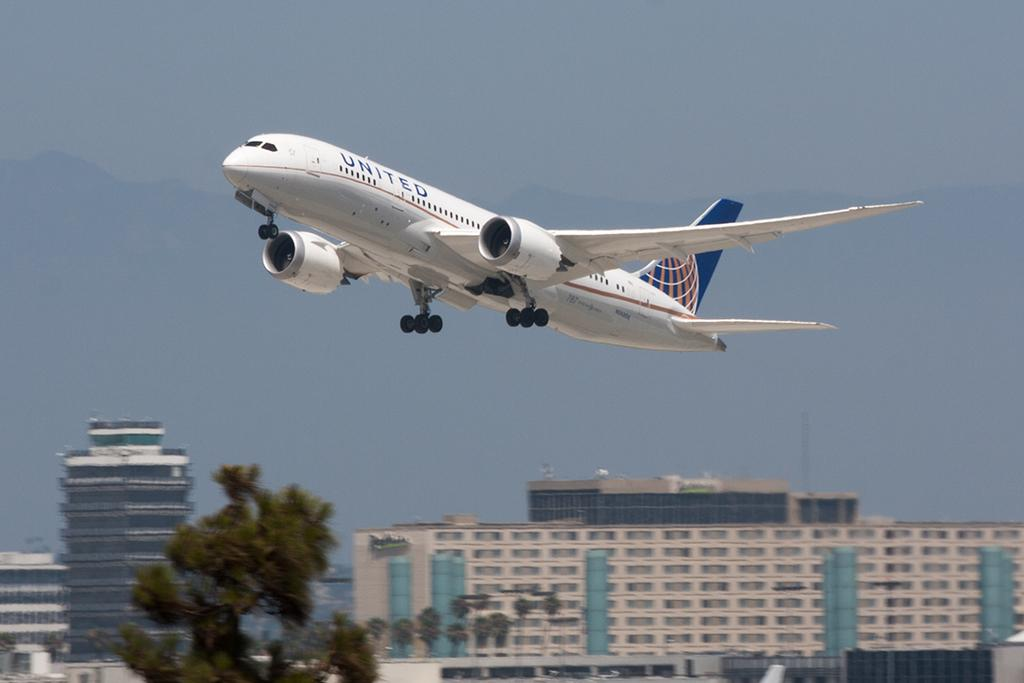<image>
Render a clear and concise summary of the photo. United flies low above the multiple buildings below. 